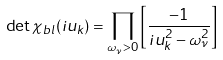<formula> <loc_0><loc_0><loc_500><loc_500>\det \chi _ { b l } ( i u _ { k } ) = \prod _ { \omega _ { \nu } > 0 } \left [ \frac { - 1 } { i u _ { k } ^ { 2 } - \omega _ { \nu } ^ { 2 } } \right ]</formula> 